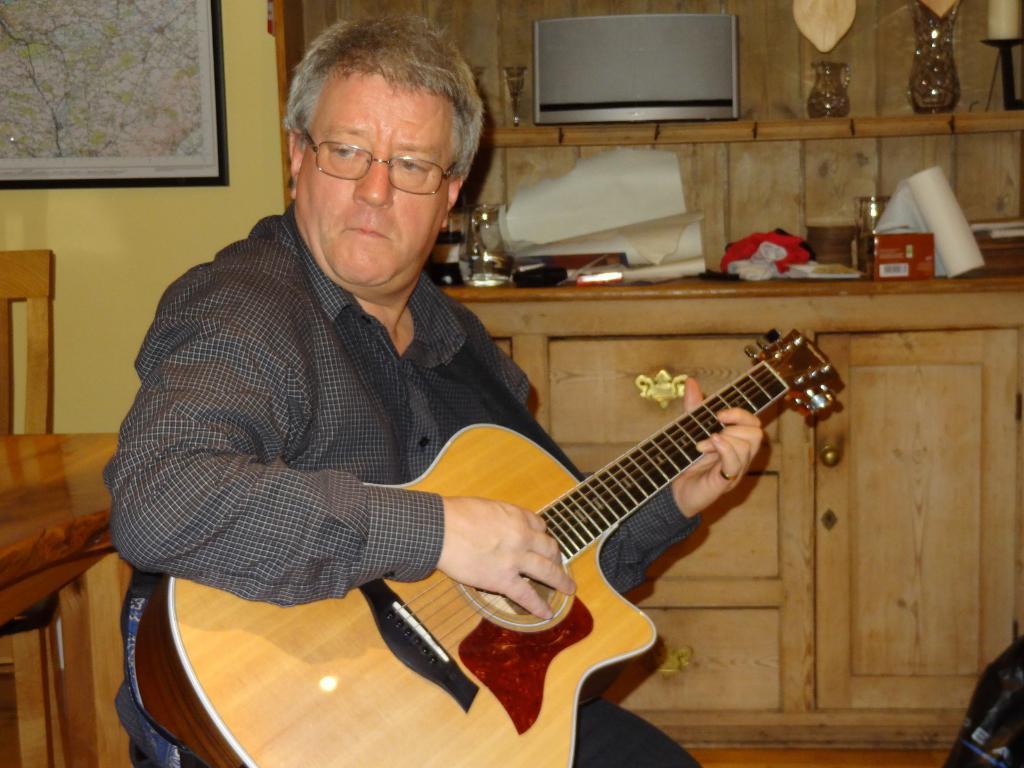Please provide a concise description of this image. In this image I can see a man is holding a guitar and he is wearing a specs. In the background I can see a map on this wall and a chair. 